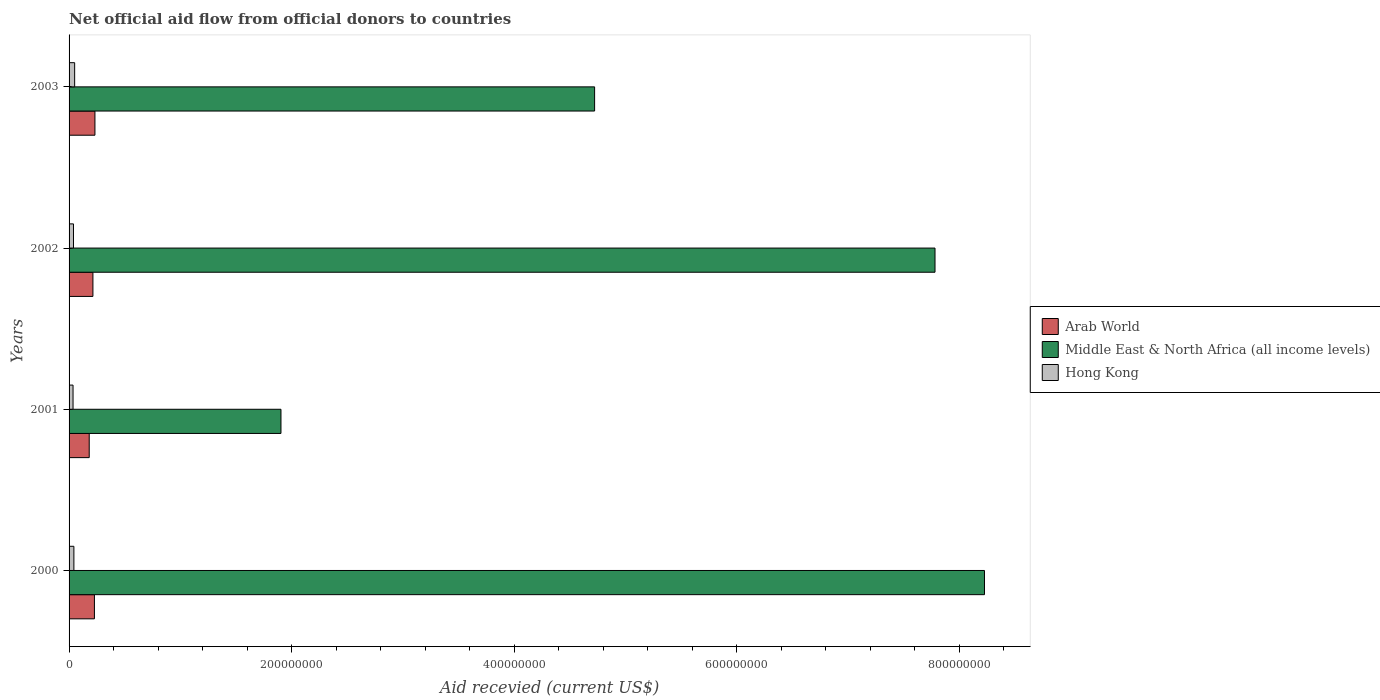How many different coloured bars are there?
Offer a very short reply. 3. Are the number of bars on each tick of the Y-axis equal?
Offer a very short reply. Yes. What is the total aid received in Hong Kong in 2000?
Make the answer very short. 4.33e+06. Across all years, what is the maximum total aid received in Hong Kong?
Ensure brevity in your answer.  5.02e+06. Across all years, what is the minimum total aid received in Arab World?
Provide a short and direct response. 1.81e+07. In which year was the total aid received in Arab World minimum?
Provide a short and direct response. 2001. What is the total total aid received in Arab World in the graph?
Your answer should be very brief. 8.56e+07. What is the difference between the total aid received in Arab World in 2000 and that in 2002?
Your answer should be very brief. 1.34e+06. What is the difference between the total aid received in Arab World in 2000 and the total aid received in Middle East & North Africa (all income levels) in 2002?
Provide a succinct answer. -7.56e+08. What is the average total aid received in Hong Kong per year?
Keep it short and to the point. 4.22e+06. In the year 2003, what is the difference between the total aid received in Middle East & North Africa (all income levels) and total aid received in Hong Kong?
Provide a short and direct response. 4.67e+08. In how many years, is the total aid received in Arab World greater than 80000000 US$?
Provide a short and direct response. 0. What is the ratio of the total aid received in Arab World in 2002 to that in 2003?
Your answer should be compact. 0.92. What is the difference between the highest and the lowest total aid received in Middle East & North Africa (all income levels)?
Offer a very short reply. 6.32e+08. Is the sum of the total aid received in Middle East & North Africa (all income levels) in 2001 and 2002 greater than the maximum total aid received in Hong Kong across all years?
Provide a succinct answer. Yes. What does the 3rd bar from the top in 2002 represents?
Make the answer very short. Arab World. What does the 1st bar from the bottom in 2000 represents?
Your answer should be very brief. Arab World. How many years are there in the graph?
Offer a very short reply. 4. Does the graph contain any zero values?
Keep it short and to the point. No. Does the graph contain grids?
Offer a terse response. No. How many legend labels are there?
Your answer should be compact. 3. How are the legend labels stacked?
Your answer should be compact. Vertical. What is the title of the graph?
Keep it short and to the point. Net official aid flow from official donors to countries. Does "Ecuador" appear as one of the legend labels in the graph?
Keep it short and to the point. No. What is the label or title of the X-axis?
Give a very brief answer. Aid recevied (current US$). What is the Aid recevied (current US$) of Arab World in 2000?
Your response must be concise. 2.28e+07. What is the Aid recevied (current US$) in Middle East & North Africa (all income levels) in 2000?
Make the answer very short. 8.23e+08. What is the Aid recevied (current US$) of Hong Kong in 2000?
Ensure brevity in your answer.  4.33e+06. What is the Aid recevied (current US$) in Arab World in 2001?
Provide a succinct answer. 1.81e+07. What is the Aid recevied (current US$) in Middle East & North Africa (all income levels) in 2001?
Offer a terse response. 1.90e+08. What is the Aid recevied (current US$) of Hong Kong in 2001?
Provide a short and direct response. 3.57e+06. What is the Aid recevied (current US$) in Arab World in 2002?
Offer a very short reply. 2.14e+07. What is the Aid recevied (current US$) in Middle East & North Africa (all income levels) in 2002?
Keep it short and to the point. 7.78e+08. What is the Aid recevied (current US$) in Hong Kong in 2002?
Your response must be concise. 3.96e+06. What is the Aid recevied (current US$) of Arab World in 2003?
Your answer should be very brief. 2.32e+07. What is the Aid recevied (current US$) in Middle East & North Africa (all income levels) in 2003?
Keep it short and to the point. 4.72e+08. What is the Aid recevied (current US$) of Hong Kong in 2003?
Provide a short and direct response. 5.02e+06. Across all years, what is the maximum Aid recevied (current US$) in Arab World?
Your answer should be very brief. 2.32e+07. Across all years, what is the maximum Aid recevied (current US$) in Middle East & North Africa (all income levels)?
Make the answer very short. 8.23e+08. Across all years, what is the maximum Aid recevied (current US$) in Hong Kong?
Keep it short and to the point. 5.02e+06. Across all years, what is the minimum Aid recevied (current US$) of Arab World?
Make the answer very short. 1.81e+07. Across all years, what is the minimum Aid recevied (current US$) of Middle East & North Africa (all income levels)?
Your answer should be very brief. 1.90e+08. Across all years, what is the minimum Aid recevied (current US$) of Hong Kong?
Ensure brevity in your answer.  3.57e+06. What is the total Aid recevied (current US$) in Arab World in the graph?
Keep it short and to the point. 8.56e+07. What is the total Aid recevied (current US$) in Middle East & North Africa (all income levels) in the graph?
Offer a very short reply. 2.26e+09. What is the total Aid recevied (current US$) of Hong Kong in the graph?
Offer a terse response. 1.69e+07. What is the difference between the Aid recevied (current US$) in Arab World in 2000 and that in 2001?
Make the answer very short. 4.67e+06. What is the difference between the Aid recevied (current US$) of Middle East & North Africa (all income levels) in 2000 and that in 2001?
Your answer should be very brief. 6.32e+08. What is the difference between the Aid recevied (current US$) of Hong Kong in 2000 and that in 2001?
Your response must be concise. 7.60e+05. What is the difference between the Aid recevied (current US$) in Arab World in 2000 and that in 2002?
Provide a succinct answer. 1.34e+06. What is the difference between the Aid recevied (current US$) in Middle East & North Africa (all income levels) in 2000 and that in 2002?
Your answer should be very brief. 4.45e+07. What is the difference between the Aid recevied (current US$) of Arab World in 2000 and that in 2003?
Your answer should be very brief. -4.70e+05. What is the difference between the Aid recevied (current US$) of Middle East & North Africa (all income levels) in 2000 and that in 2003?
Offer a very short reply. 3.50e+08. What is the difference between the Aid recevied (current US$) of Hong Kong in 2000 and that in 2003?
Provide a short and direct response. -6.90e+05. What is the difference between the Aid recevied (current US$) of Arab World in 2001 and that in 2002?
Offer a very short reply. -3.33e+06. What is the difference between the Aid recevied (current US$) of Middle East & North Africa (all income levels) in 2001 and that in 2002?
Make the answer very short. -5.88e+08. What is the difference between the Aid recevied (current US$) of Hong Kong in 2001 and that in 2002?
Offer a very short reply. -3.90e+05. What is the difference between the Aid recevied (current US$) of Arab World in 2001 and that in 2003?
Your response must be concise. -5.14e+06. What is the difference between the Aid recevied (current US$) in Middle East & North Africa (all income levels) in 2001 and that in 2003?
Your answer should be very brief. -2.82e+08. What is the difference between the Aid recevied (current US$) of Hong Kong in 2001 and that in 2003?
Ensure brevity in your answer.  -1.45e+06. What is the difference between the Aid recevied (current US$) of Arab World in 2002 and that in 2003?
Offer a terse response. -1.81e+06. What is the difference between the Aid recevied (current US$) in Middle East & North Africa (all income levels) in 2002 and that in 2003?
Give a very brief answer. 3.06e+08. What is the difference between the Aid recevied (current US$) of Hong Kong in 2002 and that in 2003?
Make the answer very short. -1.06e+06. What is the difference between the Aid recevied (current US$) of Arab World in 2000 and the Aid recevied (current US$) of Middle East & North Africa (all income levels) in 2001?
Your response must be concise. -1.68e+08. What is the difference between the Aid recevied (current US$) of Arab World in 2000 and the Aid recevied (current US$) of Hong Kong in 2001?
Offer a very short reply. 1.92e+07. What is the difference between the Aid recevied (current US$) in Middle East & North Africa (all income levels) in 2000 and the Aid recevied (current US$) in Hong Kong in 2001?
Keep it short and to the point. 8.19e+08. What is the difference between the Aid recevied (current US$) in Arab World in 2000 and the Aid recevied (current US$) in Middle East & North Africa (all income levels) in 2002?
Make the answer very short. -7.56e+08. What is the difference between the Aid recevied (current US$) of Arab World in 2000 and the Aid recevied (current US$) of Hong Kong in 2002?
Offer a terse response. 1.88e+07. What is the difference between the Aid recevied (current US$) of Middle East & North Africa (all income levels) in 2000 and the Aid recevied (current US$) of Hong Kong in 2002?
Your response must be concise. 8.19e+08. What is the difference between the Aid recevied (current US$) of Arab World in 2000 and the Aid recevied (current US$) of Middle East & North Africa (all income levels) in 2003?
Keep it short and to the point. -4.50e+08. What is the difference between the Aid recevied (current US$) of Arab World in 2000 and the Aid recevied (current US$) of Hong Kong in 2003?
Give a very brief answer. 1.78e+07. What is the difference between the Aid recevied (current US$) in Middle East & North Africa (all income levels) in 2000 and the Aid recevied (current US$) in Hong Kong in 2003?
Give a very brief answer. 8.18e+08. What is the difference between the Aid recevied (current US$) of Arab World in 2001 and the Aid recevied (current US$) of Middle East & North Africa (all income levels) in 2002?
Your answer should be very brief. -7.60e+08. What is the difference between the Aid recevied (current US$) in Arab World in 2001 and the Aid recevied (current US$) in Hong Kong in 2002?
Offer a very short reply. 1.42e+07. What is the difference between the Aid recevied (current US$) in Middle East & North Africa (all income levels) in 2001 and the Aid recevied (current US$) in Hong Kong in 2002?
Offer a terse response. 1.86e+08. What is the difference between the Aid recevied (current US$) in Arab World in 2001 and the Aid recevied (current US$) in Middle East & North Africa (all income levels) in 2003?
Provide a succinct answer. -4.54e+08. What is the difference between the Aid recevied (current US$) of Arab World in 2001 and the Aid recevied (current US$) of Hong Kong in 2003?
Provide a short and direct response. 1.31e+07. What is the difference between the Aid recevied (current US$) in Middle East & North Africa (all income levels) in 2001 and the Aid recevied (current US$) in Hong Kong in 2003?
Offer a very short reply. 1.85e+08. What is the difference between the Aid recevied (current US$) of Arab World in 2002 and the Aid recevied (current US$) of Middle East & North Africa (all income levels) in 2003?
Make the answer very short. -4.51e+08. What is the difference between the Aid recevied (current US$) of Arab World in 2002 and the Aid recevied (current US$) of Hong Kong in 2003?
Make the answer very short. 1.64e+07. What is the difference between the Aid recevied (current US$) in Middle East & North Africa (all income levels) in 2002 and the Aid recevied (current US$) in Hong Kong in 2003?
Keep it short and to the point. 7.73e+08. What is the average Aid recevied (current US$) of Arab World per year?
Ensure brevity in your answer.  2.14e+07. What is the average Aid recevied (current US$) in Middle East & North Africa (all income levels) per year?
Ensure brevity in your answer.  5.66e+08. What is the average Aid recevied (current US$) of Hong Kong per year?
Ensure brevity in your answer.  4.22e+06. In the year 2000, what is the difference between the Aid recevied (current US$) of Arab World and Aid recevied (current US$) of Middle East & North Africa (all income levels)?
Offer a terse response. -8.00e+08. In the year 2000, what is the difference between the Aid recevied (current US$) of Arab World and Aid recevied (current US$) of Hong Kong?
Your response must be concise. 1.84e+07. In the year 2000, what is the difference between the Aid recevied (current US$) in Middle East & North Africa (all income levels) and Aid recevied (current US$) in Hong Kong?
Offer a very short reply. 8.18e+08. In the year 2001, what is the difference between the Aid recevied (current US$) of Arab World and Aid recevied (current US$) of Middle East & North Africa (all income levels)?
Make the answer very short. -1.72e+08. In the year 2001, what is the difference between the Aid recevied (current US$) of Arab World and Aid recevied (current US$) of Hong Kong?
Your answer should be compact. 1.45e+07. In the year 2001, what is the difference between the Aid recevied (current US$) of Middle East & North Africa (all income levels) and Aid recevied (current US$) of Hong Kong?
Offer a terse response. 1.87e+08. In the year 2002, what is the difference between the Aid recevied (current US$) of Arab World and Aid recevied (current US$) of Middle East & North Africa (all income levels)?
Offer a terse response. -7.57e+08. In the year 2002, what is the difference between the Aid recevied (current US$) in Arab World and Aid recevied (current US$) in Hong Kong?
Keep it short and to the point. 1.75e+07. In the year 2002, what is the difference between the Aid recevied (current US$) of Middle East & North Africa (all income levels) and Aid recevied (current US$) of Hong Kong?
Your answer should be very brief. 7.74e+08. In the year 2003, what is the difference between the Aid recevied (current US$) of Arab World and Aid recevied (current US$) of Middle East & North Africa (all income levels)?
Offer a terse response. -4.49e+08. In the year 2003, what is the difference between the Aid recevied (current US$) of Arab World and Aid recevied (current US$) of Hong Kong?
Keep it short and to the point. 1.82e+07. In the year 2003, what is the difference between the Aid recevied (current US$) in Middle East & North Africa (all income levels) and Aid recevied (current US$) in Hong Kong?
Ensure brevity in your answer.  4.67e+08. What is the ratio of the Aid recevied (current US$) in Arab World in 2000 to that in 2001?
Your answer should be very brief. 1.26. What is the ratio of the Aid recevied (current US$) in Middle East & North Africa (all income levels) in 2000 to that in 2001?
Provide a short and direct response. 4.32. What is the ratio of the Aid recevied (current US$) of Hong Kong in 2000 to that in 2001?
Ensure brevity in your answer.  1.21. What is the ratio of the Aid recevied (current US$) in Arab World in 2000 to that in 2002?
Offer a very short reply. 1.06. What is the ratio of the Aid recevied (current US$) in Middle East & North Africa (all income levels) in 2000 to that in 2002?
Offer a terse response. 1.06. What is the ratio of the Aid recevied (current US$) of Hong Kong in 2000 to that in 2002?
Give a very brief answer. 1.09. What is the ratio of the Aid recevied (current US$) of Arab World in 2000 to that in 2003?
Your answer should be very brief. 0.98. What is the ratio of the Aid recevied (current US$) of Middle East & North Africa (all income levels) in 2000 to that in 2003?
Your answer should be very brief. 1.74. What is the ratio of the Aid recevied (current US$) in Hong Kong in 2000 to that in 2003?
Make the answer very short. 0.86. What is the ratio of the Aid recevied (current US$) of Arab World in 2001 to that in 2002?
Ensure brevity in your answer.  0.84. What is the ratio of the Aid recevied (current US$) of Middle East & North Africa (all income levels) in 2001 to that in 2002?
Your answer should be very brief. 0.24. What is the ratio of the Aid recevied (current US$) of Hong Kong in 2001 to that in 2002?
Give a very brief answer. 0.9. What is the ratio of the Aid recevied (current US$) in Arab World in 2001 to that in 2003?
Offer a very short reply. 0.78. What is the ratio of the Aid recevied (current US$) of Middle East & North Africa (all income levels) in 2001 to that in 2003?
Your answer should be very brief. 0.4. What is the ratio of the Aid recevied (current US$) of Hong Kong in 2001 to that in 2003?
Give a very brief answer. 0.71. What is the ratio of the Aid recevied (current US$) in Arab World in 2002 to that in 2003?
Keep it short and to the point. 0.92. What is the ratio of the Aid recevied (current US$) of Middle East & North Africa (all income levels) in 2002 to that in 2003?
Your response must be concise. 1.65. What is the ratio of the Aid recevied (current US$) in Hong Kong in 2002 to that in 2003?
Your answer should be very brief. 0.79. What is the difference between the highest and the second highest Aid recevied (current US$) of Arab World?
Provide a succinct answer. 4.70e+05. What is the difference between the highest and the second highest Aid recevied (current US$) in Middle East & North Africa (all income levels)?
Your answer should be compact. 4.45e+07. What is the difference between the highest and the second highest Aid recevied (current US$) of Hong Kong?
Keep it short and to the point. 6.90e+05. What is the difference between the highest and the lowest Aid recevied (current US$) of Arab World?
Your answer should be very brief. 5.14e+06. What is the difference between the highest and the lowest Aid recevied (current US$) in Middle East & North Africa (all income levels)?
Ensure brevity in your answer.  6.32e+08. What is the difference between the highest and the lowest Aid recevied (current US$) in Hong Kong?
Your answer should be very brief. 1.45e+06. 